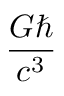<formula> <loc_0><loc_0><loc_500><loc_500>\frac { G } { c ^ { 3 } }</formula> 